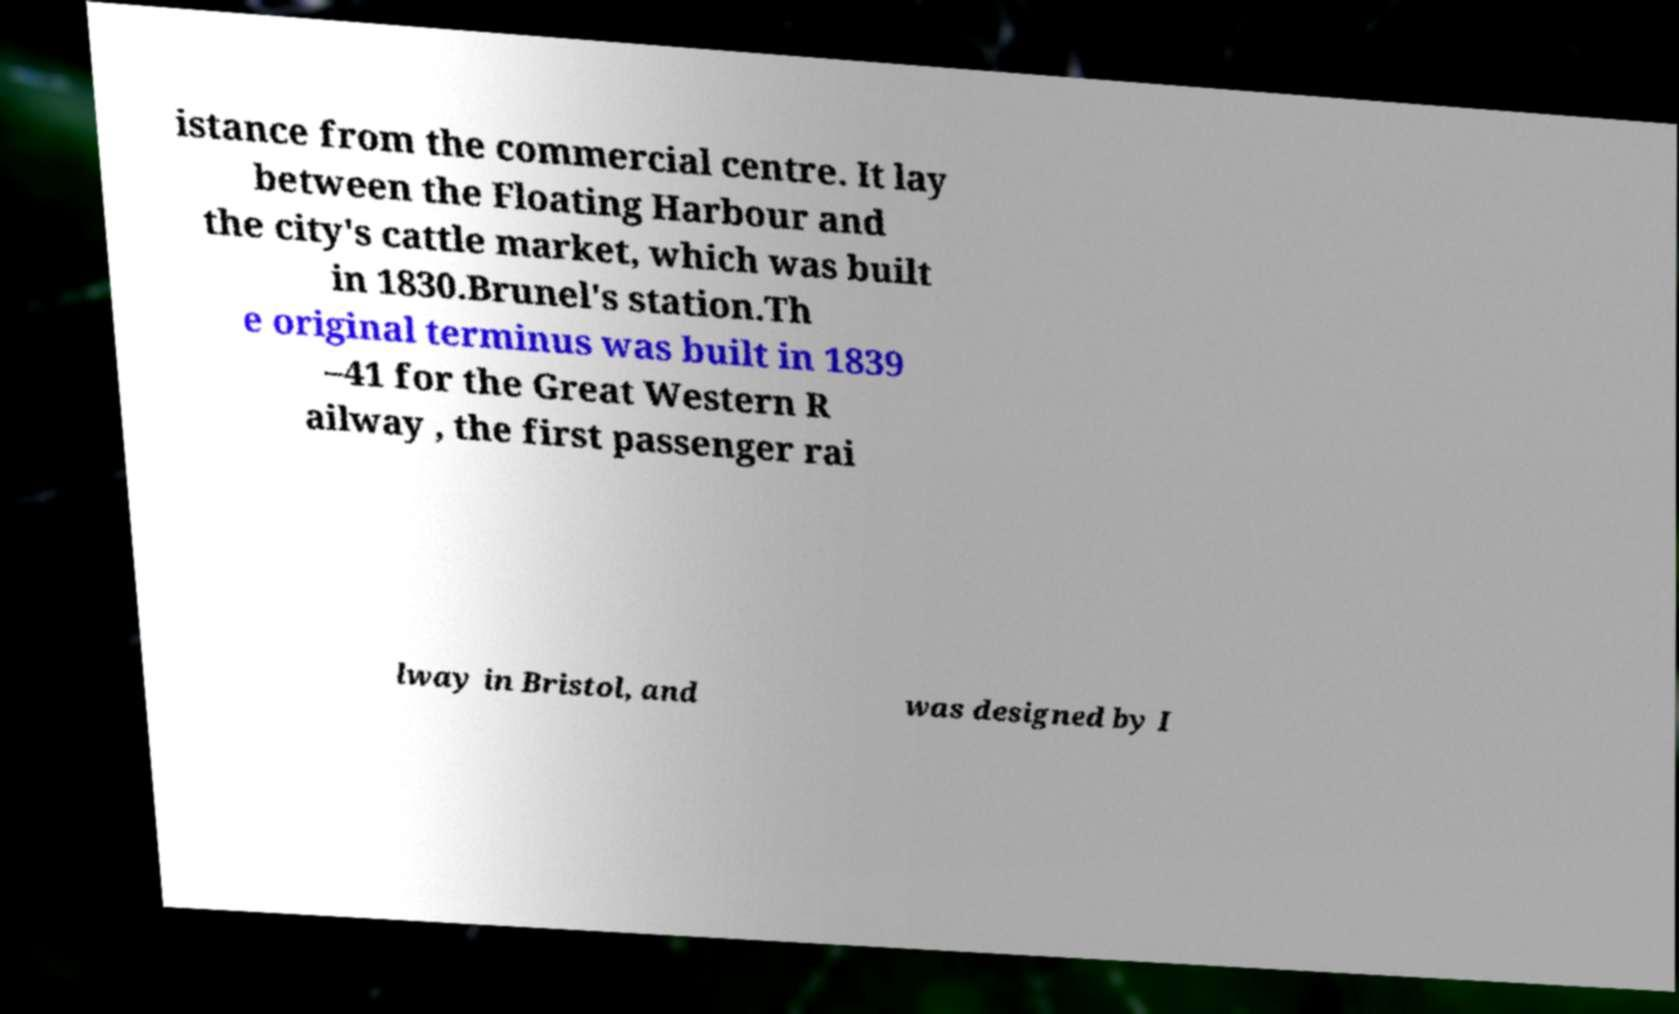Could you assist in decoding the text presented in this image and type it out clearly? istance from the commercial centre. It lay between the Floating Harbour and the city's cattle market, which was built in 1830.Brunel's station.Th e original terminus was built in 1839 –41 for the Great Western R ailway , the first passenger rai lway in Bristol, and was designed by I 